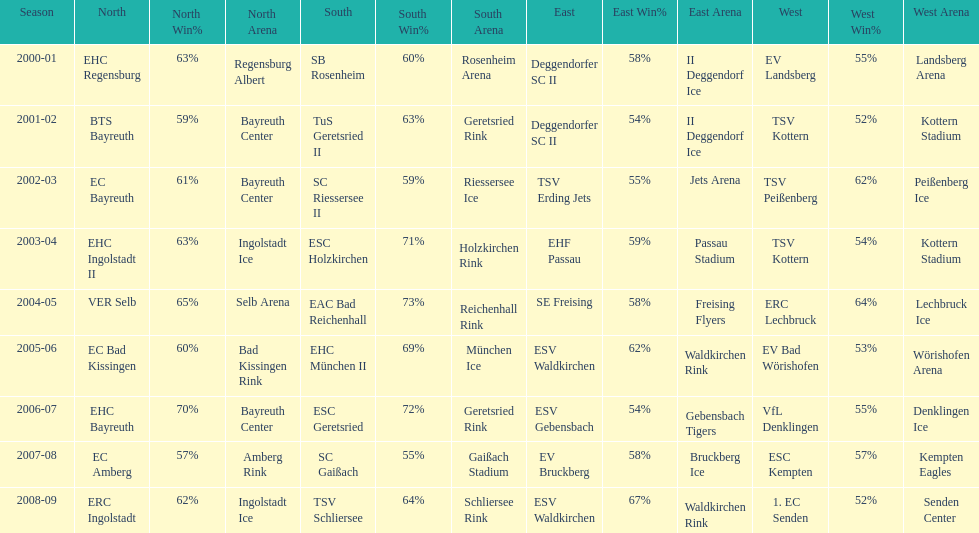Which name appears more often, kottern or bayreuth? Bayreuth. 